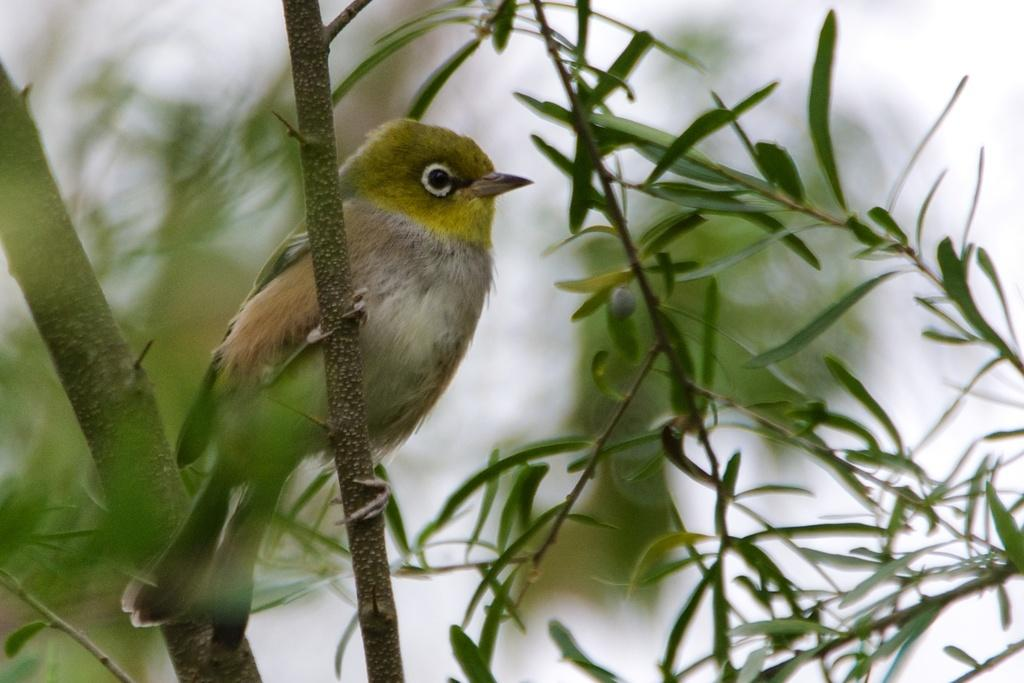What type of animal can be seen in the image? There is a bird in the image. What other living organisms are present in the image? There are plants in the image. Can you describe the background of the image? The background of the image is blurry. What type of work is the bird doing in the image? The image does not show the bird performing any work or task, so it cannot be determined from the image. 